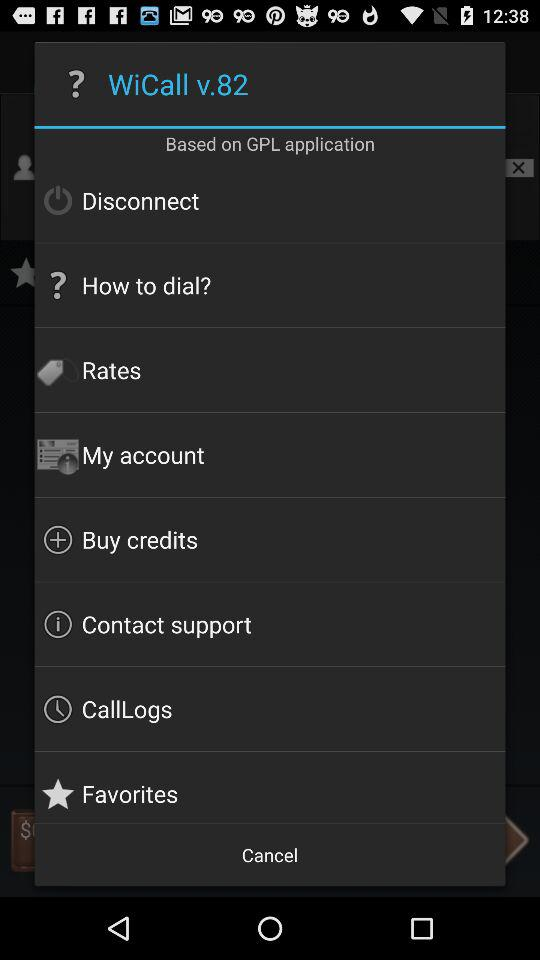Which version is used? The used version is v.82. 